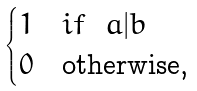Convert formula to latex. <formula><loc_0><loc_0><loc_500><loc_500>\begin{cases} 1 & i f \ \ a | b \\ 0 & \text {otherwise, } \end{cases}</formula> 